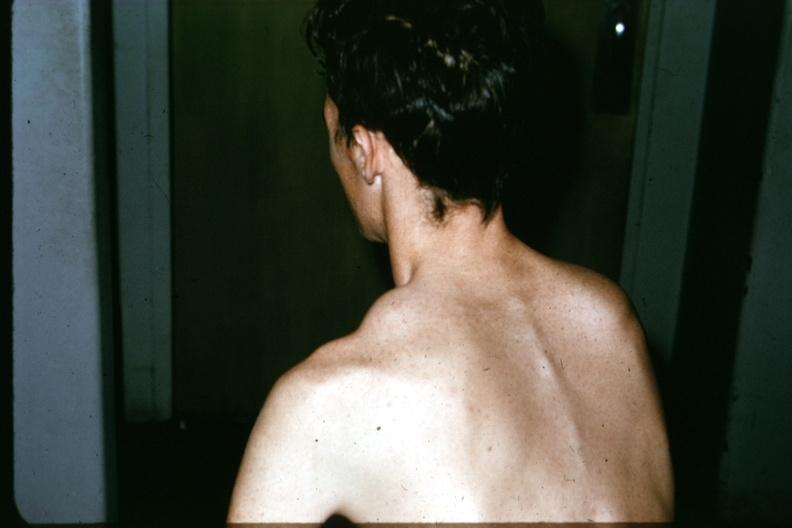what does this image show?
Answer the question using a single word or phrase. Patient before surgery lesion in clavicle 